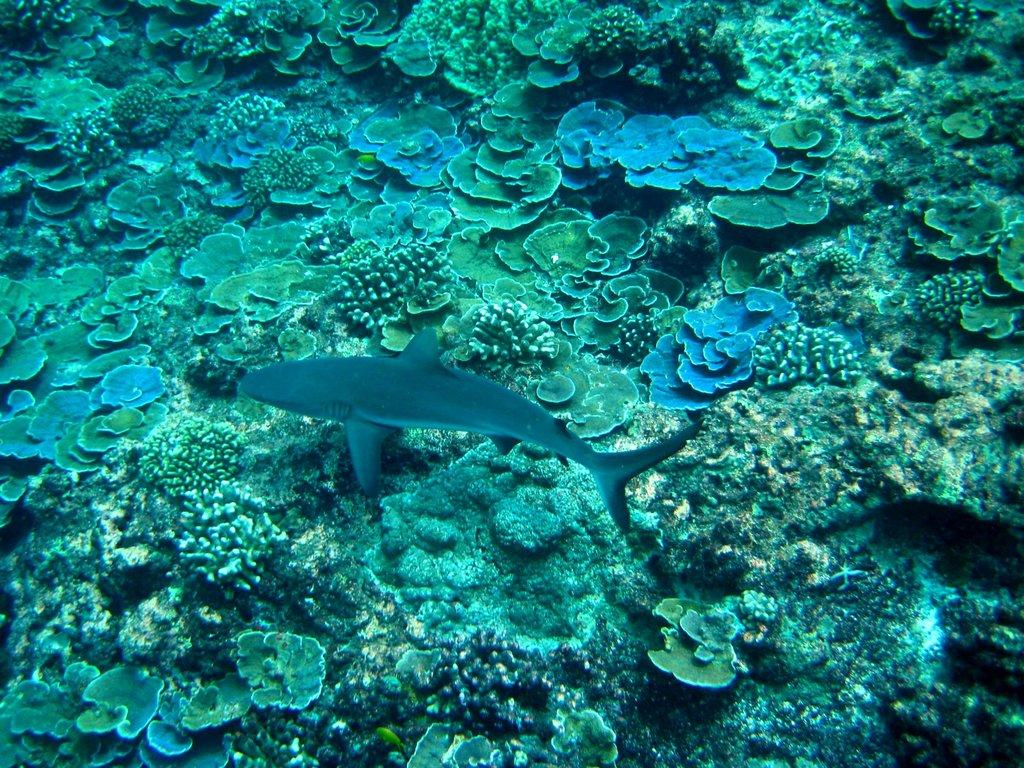What type of animals can be seen in the image? There are fish in the water. What natural formation is visible in the image? There is a coral reef visible in the image. What type of alarm can be heard in the image? There is no alarm present in the image, as it is a photograph of fish and coral reef. 